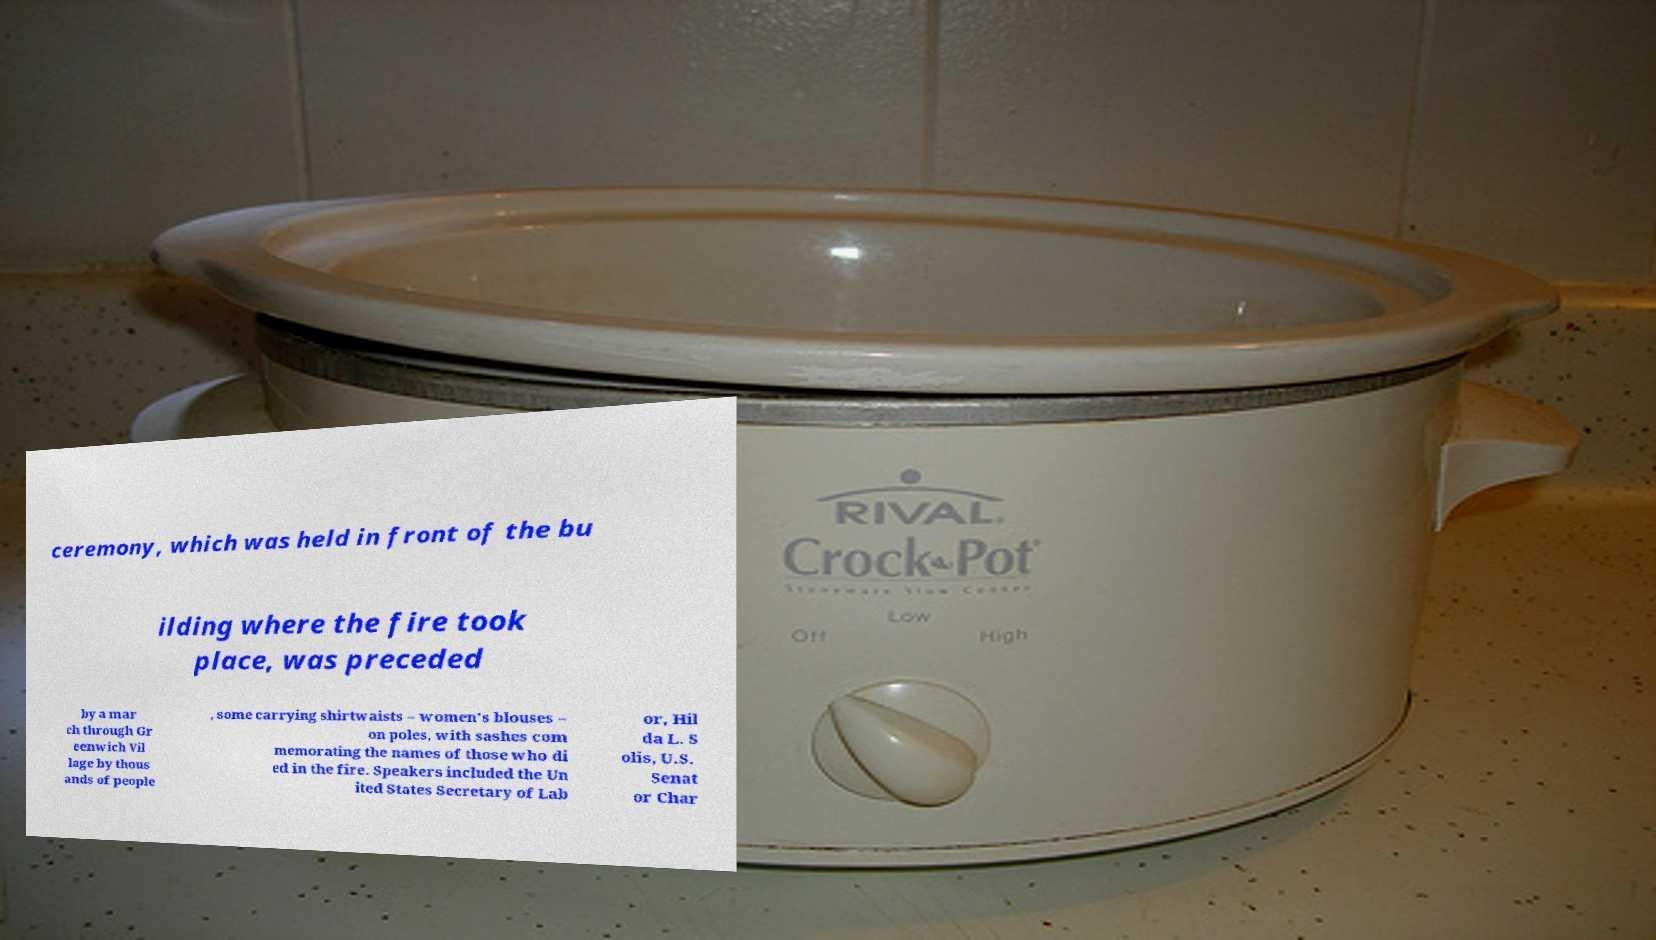I need the written content from this picture converted into text. Can you do that? ceremony, which was held in front of the bu ilding where the fire took place, was preceded by a mar ch through Gr eenwich Vil lage by thous ands of people , some carrying shirtwaists – women's blouses – on poles, with sashes com memorating the names of those who di ed in the fire. Speakers included the Un ited States Secretary of Lab or, Hil da L. S olis, U.S. Senat or Char 